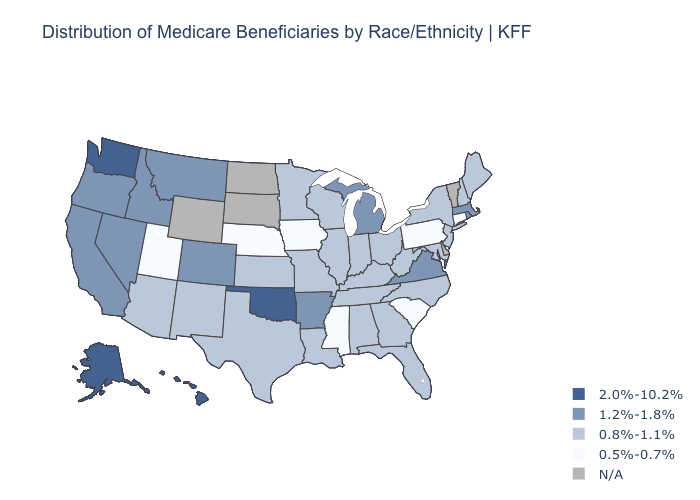Name the states that have a value in the range 1.2%-1.8%?
Concise answer only. Arkansas, California, Colorado, Idaho, Massachusetts, Michigan, Montana, Nevada, Oregon, Rhode Island, Virginia. What is the value of New York?
Be succinct. 0.8%-1.1%. What is the lowest value in the Northeast?
Give a very brief answer. 0.5%-0.7%. Among the states that border Georgia , which have the highest value?
Be succinct. Alabama, Florida, North Carolina, Tennessee. Does the map have missing data?
Keep it brief. Yes. Name the states that have a value in the range 0.8%-1.1%?
Write a very short answer. Alabama, Arizona, Florida, Georgia, Illinois, Indiana, Kansas, Kentucky, Louisiana, Maine, Maryland, Minnesota, Missouri, New Hampshire, New Jersey, New Mexico, New York, North Carolina, Ohio, Tennessee, Texas, West Virginia, Wisconsin. Does Hawaii have the highest value in the USA?
Give a very brief answer. Yes. Does Mississippi have the lowest value in the USA?
Keep it brief. Yes. Does Iowa have the lowest value in the USA?
Write a very short answer. Yes. Name the states that have a value in the range 2.0%-10.2%?
Write a very short answer. Alaska, Hawaii, Oklahoma, Washington. What is the value of Pennsylvania?
Answer briefly. 0.5%-0.7%. Does Massachusetts have the lowest value in the Northeast?
Short answer required. No. What is the value of South Carolina?
Concise answer only. 0.5%-0.7%. Does the map have missing data?
Short answer required. Yes. 